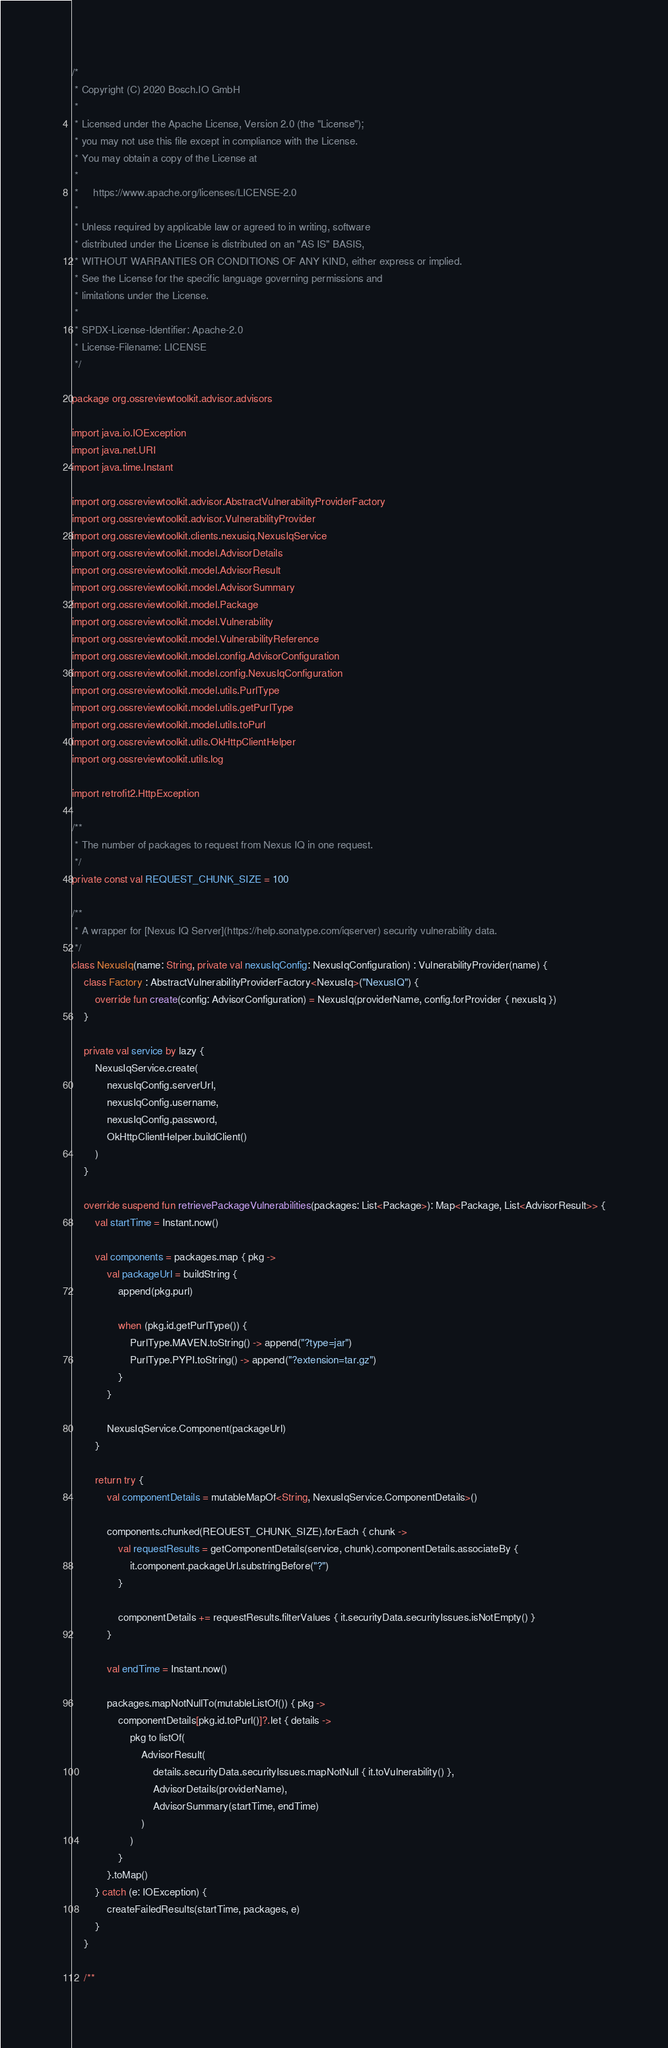<code> <loc_0><loc_0><loc_500><loc_500><_Kotlin_>/*
 * Copyright (C) 2020 Bosch.IO GmbH
 *
 * Licensed under the Apache License, Version 2.0 (the "License");
 * you may not use this file except in compliance with the License.
 * You may obtain a copy of the License at
 *
 *     https://www.apache.org/licenses/LICENSE-2.0
 *
 * Unless required by applicable law or agreed to in writing, software
 * distributed under the License is distributed on an "AS IS" BASIS,
 * WITHOUT WARRANTIES OR CONDITIONS OF ANY KIND, either express or implied.
 * See the License for the specific language governing permissions and
 * limitations under the License.
 *
 * SPDX-License-Identifier: Apache-2.0
 * License-Filename: LICENSE
 */

package org.ossreviewtoolkit.advisor.advisors

import java.io.IOException
import java.net.URI
import java.time.Instant

import org.ossreviewtoolkit.advisor.AbstractVulnerabilityProviderFactory
import org.ossreviewtoolkit.advisor.VulnerabilityProvider
import org.ossreviewtoolkit.clients.nexusiq.NexusIqService
import org.ossreviewtoolkit.model.AdvisorDetails
import org.ossreviewtoolkit.model.AdvisorResult
import org.ossreviewtoolkit.model.AdvisorSummary
import org.ossreviewtoolkit.model.Package
import org.ossreviewtoolkit.model.Vulnerability
import org.ossreviewtoolkit.model.VulnerabilityReference
import org.ossreviewtoolkit.model.config.AdvisorConfiguration
import org.ossreviewtoolkit.model.config.NexusIqConfiguration
import org.ossreviewtoolkit.model.utils.PurlType
import org.ossreviewtoolkit.model.utils.getPurlType
import org.ossreviewtoolkit.model.utils.toPurl
import org.ossreviewtoolkit.utils.OkHttpClientHelper
import org.ossreviewtoolkit.utils.log

import retrofit2.HttpException

/**
 * The number of packages to request from Nexus IQ in one request.
 */
private const val REQUEST_CHUNK_SIZE = 100

/**
 * A wrapper for [Nexus IQ Server](https://help.sonatype.com/iqserver) security vulnerability data.
 */
class NexusIq(name: String, private val nexusIqConfig: NexusIqConfiguration) : VulnerabilityProvider(name) {
    class Factory : AbstractVulnerabilityProviderFactory<NexusIq>("NexusIQ") {
        override fun create(config: AdvisorConfiguration) = NexusIq(providerName, config.forProvider { nexusIq })
    }

    private val service by lazy {
        NexusIqService.create(
            nexusIqConfig.serverUrl,
            nexusIqConfig.username,
            nexusIqConfig.password,
            OkHttpClientHelper.buildClient()
        )
    }

    override suspend fun retrievePackageVulnerabilities(packages: List<Package>): Map<Package, List<AdvisorResult>> {
        val startTime = Instant.now()

        val components = packages.map { pkg ->
            val packageUrl = buildString {
                append(pkg.purl)

                when (pkg.id.getPurlType()) {
                    PurlType.MAVEN.toString() -> append("?type=jar")
                    PurlType.PYPI.toString() -> append("?extension=tar.gz")
                }
            }

            NexusIqService.Component(packageUrl)
        }

        return try {
            val componentDetails = mutableMapOf<String, NexusIqService.ComponentDetails>()

            components.chunked(REQUEST_CHUNK_SIZE).forEach { chunk ->
                val requestResults = getComponentDetails(service, chunk).componentDetails.associateBy {
                    it.component.packageUrl.substringBefore("?")
                }

                componentDetails += requestResults.filterValues { it.securityData.securityIssues.isNotEmpty() }
            }

            val endTime = Instant.now()

            packages.mapNotNullTo(mutableListOf()) { pkg ->
                componentDetails[pkg.id.toPurl()]?.let { details ->
                    pkg to listOf(
                        AdvisorResult(
                            details.securityData.securityIssues.mapNotNull { it.toVulnerability() },
                            AdvisorDetails(providerName),
                            AdvisorSummary(startTime, endTime)
                        )
                    )
                }
            }.toMap()
        } catch (e: IOException) {
            createFailedResults(startTime, packages, e)
        }
    }

    /**</code> 